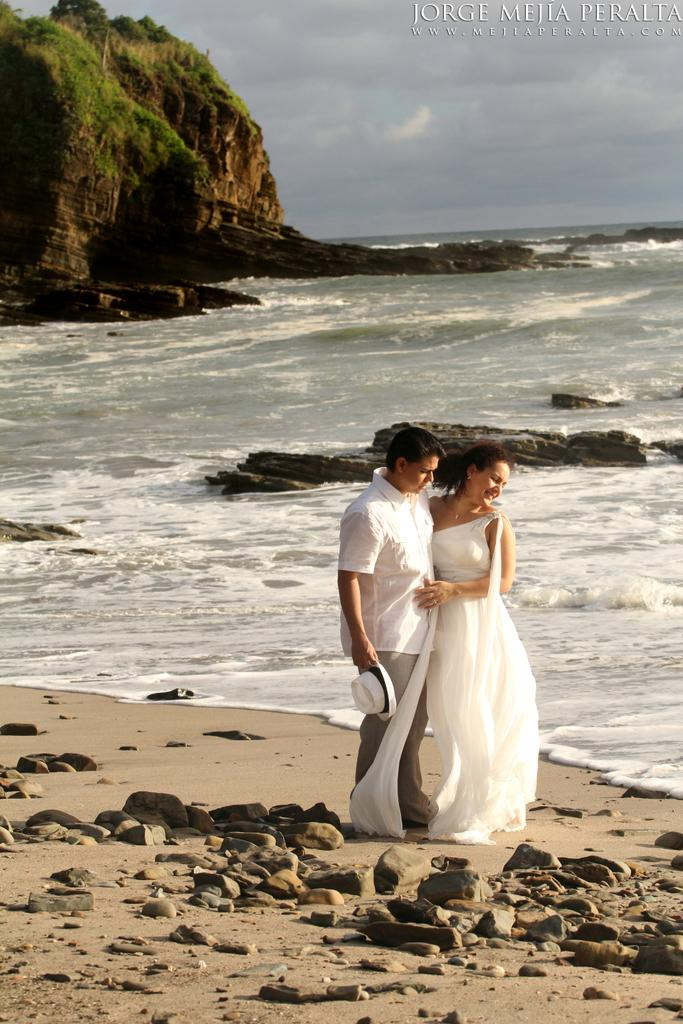How many people are present in the image? There is a man and a woman in the image. What is the setting of the image? The image features stones, water, and a mountain in the background. What can be seen in the sky in the image? The sky is visible in the background of the image. What type of flowers can be seen in the cemetery in the image? There is no cemetery present in the image; it features a man, a woman, stones, water, a mountain, and the sky. 